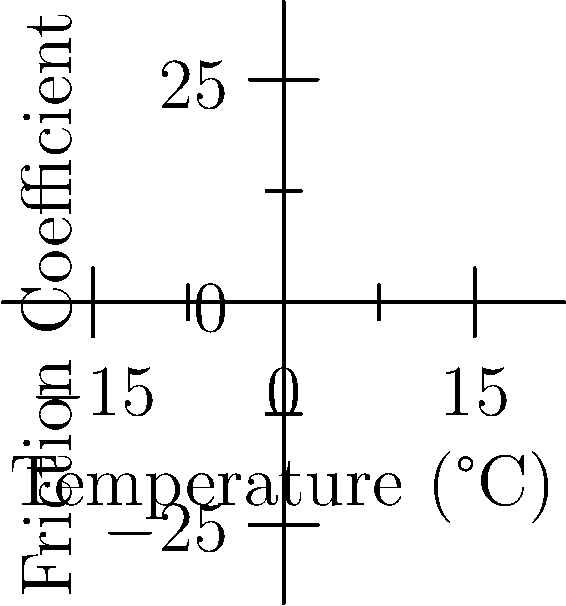As a former hockey player, you know that ice temperature affects skate blade friction. The graph shows the relationship between ice temperature and friction coefficient for cold and warm ice. At 0°C, what's the approximate difference in friction coefficients between cold and warm ice? To solve this problem, we need to follow these steps:

1. Identify the friction coefficient for cold ice at 0°C:
   From the blue line (cold ice), we can see that at 0°C, the friction coefficient is approximately 0.05.

2. Identify the friction coefficient for warm ice at 0°C:
   From the red line (warm ice), we can see that at 0°C, the friction coefficient is approximately 0.03.

3. Calculate the difference between these two values:
   Difference = Cold ice friction coefficient - Warm ice friction coefficient
   $$ \text{Difference} = 0.05 - 0.03 = 0.02 $$

Therefore, the approximate difference in friction coefficients between cold and warm ice at 0°C is 0.02.
Answer: 0.02 